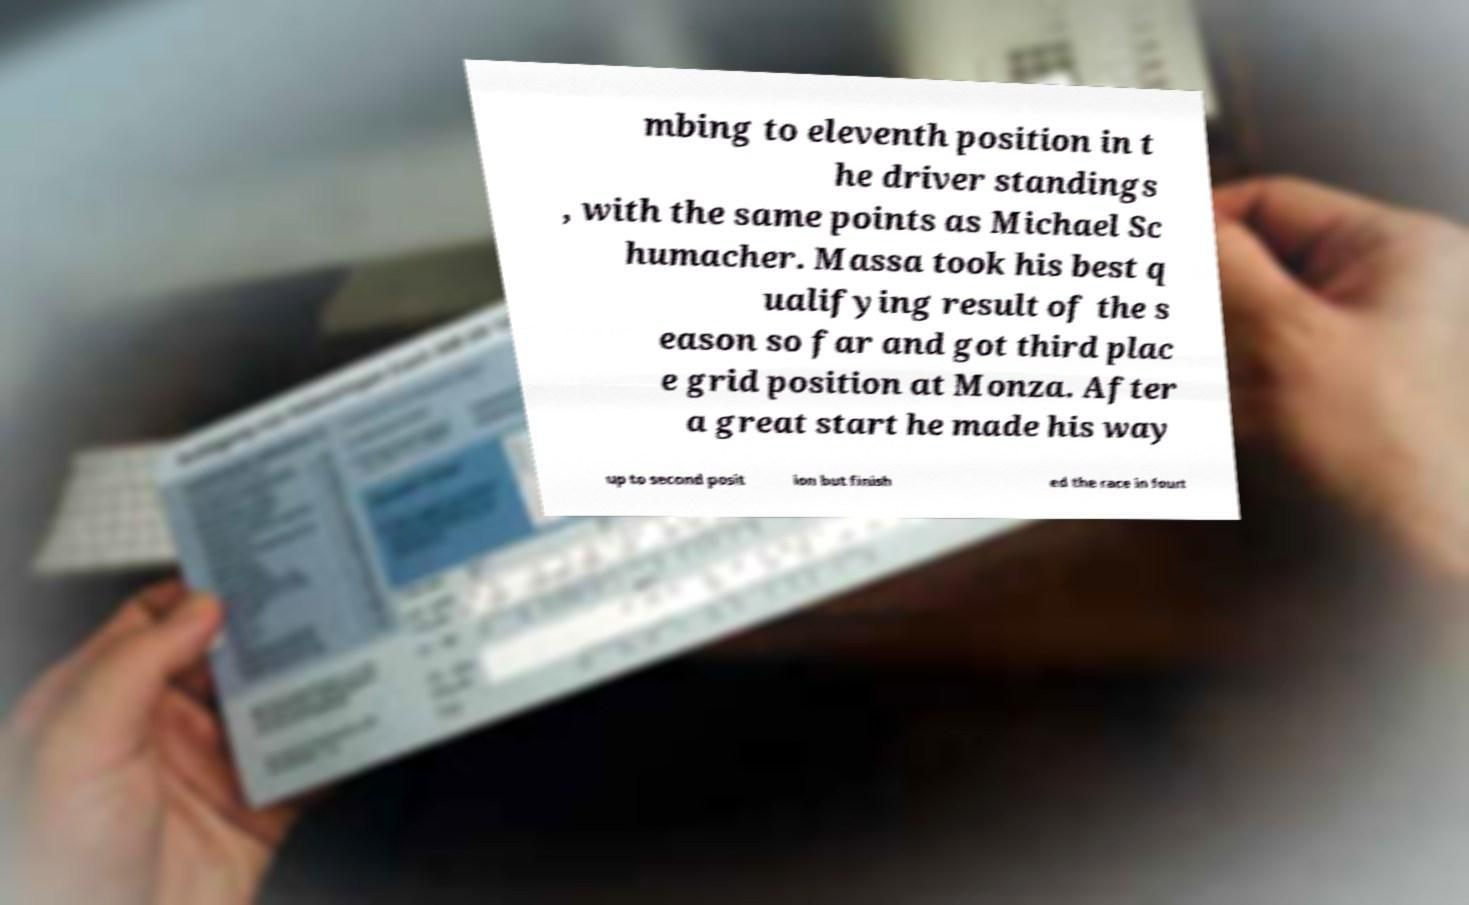Can you read and provide the text displayed in the image?This photo seems to have some interesting text. Can you extract and type it out for me? mbing to eleventh position in t he driver standings , with the same points as Michael Sc humacher. Massa took his best q ualifying result of the s eason so far and got third plac e grid position at Monza. After a great start he made his way up to second posit ion but finish ed the race in fourt 